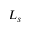<formula> <loc_0><loc_0><loc_500><loc_500>L _ { s }</formula> 